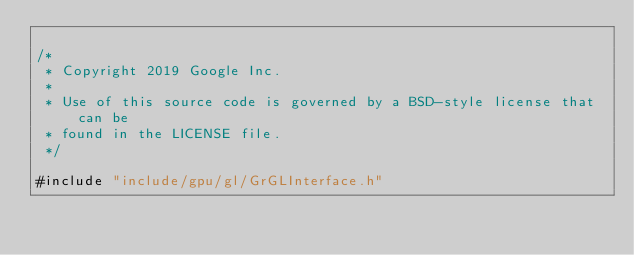Convert code to text. <code><loc_0><loc_0><loc_500><loc_500><_ObjectiveC_>
/*
 * Copyright 2019 Google Inc.
 *
 * Use of this source code is governed by a BSD-style license that can be
 * found in the LICENSE file.
 */

#include "include/gpu/gl/GrGLInterface.h"</code> 